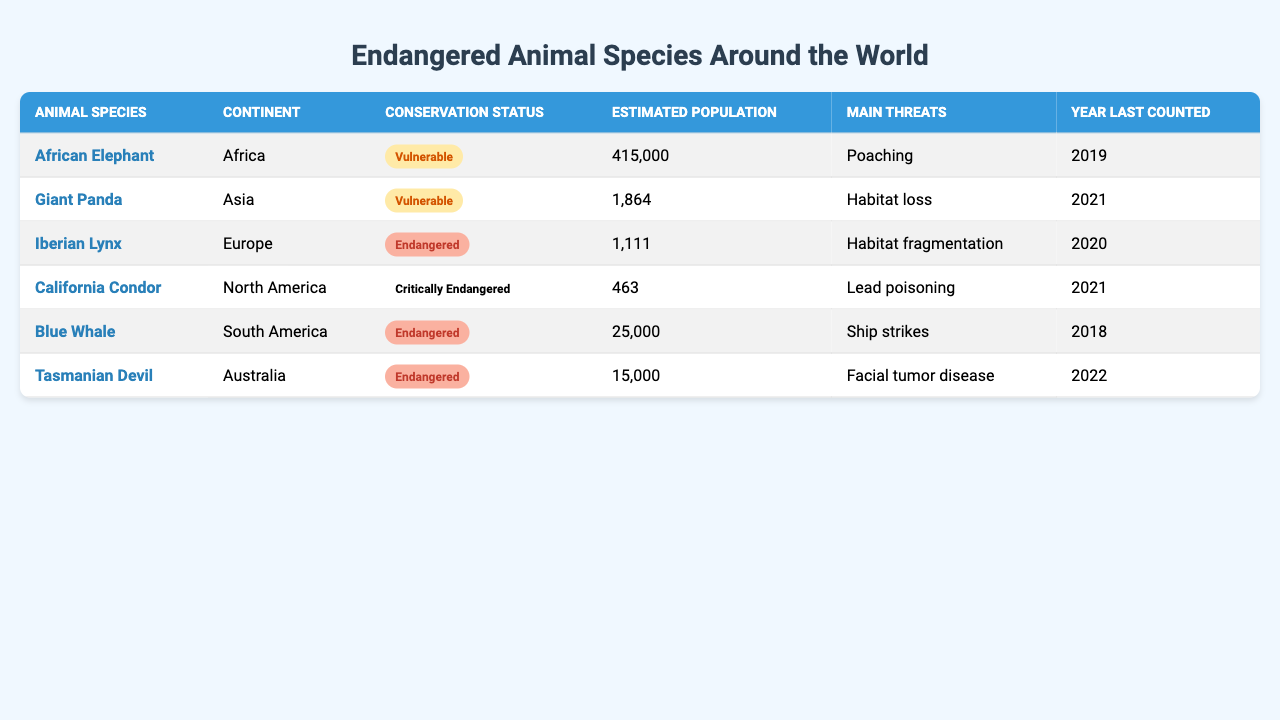What is the conservation status of the California Condor? The table indicates that the California Condor is listed as "Critically Endangered."
Answer: Critically Endangered How many estimated African Elephants are left? According to the table, the estimated population of African Elephants is 415,000.
Answer: 415,000 Which animal has the lowest estimated population? The Iberian Lynx has the lowest estimated population, which is 1,111.
Answer: 1,111 What is the main threat faced by the Giant Panda? The main threat to the Giant Panda is habitat loss, as noted in the table.
Answer: Habitat loss How many endangered species are listed in the table? The table shows that there are three endangered species: Blue Whale, Tasmanian Devil, and Giant Panda.
Answer: 3 What was the year of the last count for the Tasmanian Devil? The last count for the Tasmanian Devil was in 2022, as mentioned in the table.
Answer: 2022 Which continent has the highest number of endangered species? Africa has the highest number of endangered species listed with 1 (African Elephant), while other continents have 1 each as well, leading to a tie.
Answer: None (tie) What are the main threats facing the Blue Whale? The Blue Whale faces ship strikes as the main threat, as listed in the table.
Answer: Ship strikes Is the estimated population of the California Condor greater than that of the Tasmanian Devil? The table shows that the California Condor has an estimated population of 463, while the Tasmanian Devil has 15,000, so this statement is false.
Answer: No What is the average estimated population of the species listed on the table? To find the average, sum all estimated populations: (415000 + 1864 + 1111 + 463 + 25000 + 15000) = 441438. Then, divide by 6 species: 441438 / 6 = 73656.33.
Answer: 73656.33 